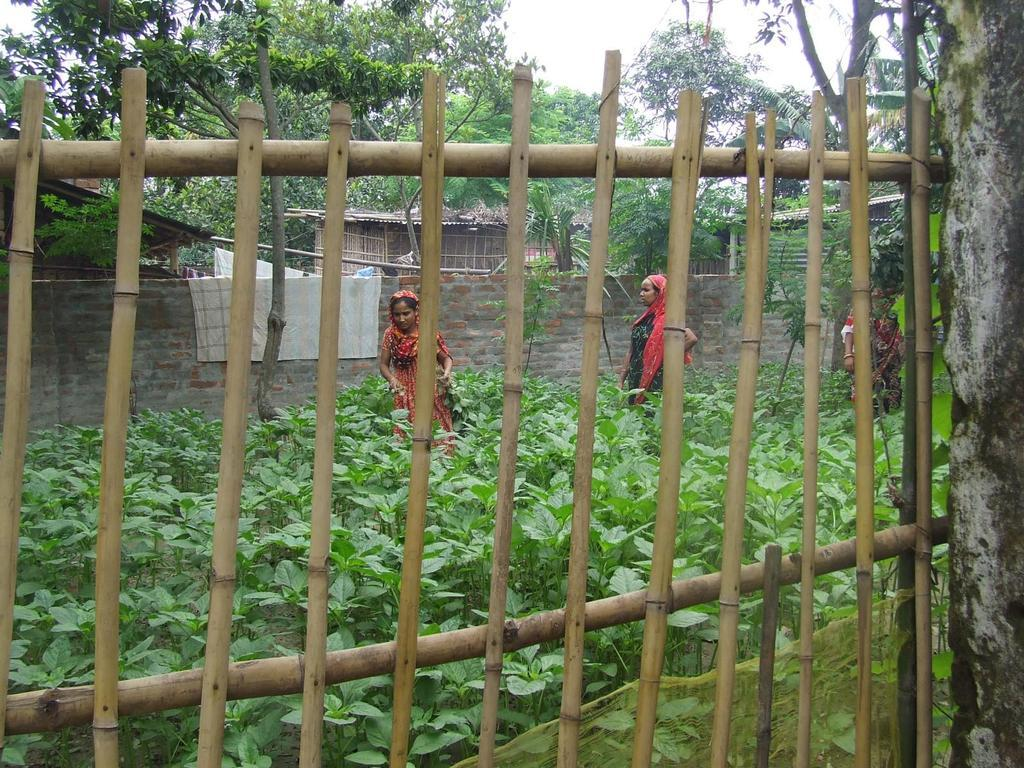What is located in the foreground of the image? There is a fence, three women, and plants in the foreground of the image. Can you describe the setting in the foreground? The foreground features a fence, three women, and plants. What can be seen in the background of the image? There are houses, trees, and the sky visible in the background of the image. What time of day might the image have been taken? The image was likely taken during the day, as the sky is visible and not dark. What type of oatmeal is being served for breakfast in the image? There is no oatmeal or indication of a meal in the image; it features a fence, three women, plants, houses, trees, and the sky. What type of destruction can be seen in the image? There is no destruction or indication of any damage in the image; it features a peaceful scene with a fence, three women, plants, houses, trees, and the sky. 